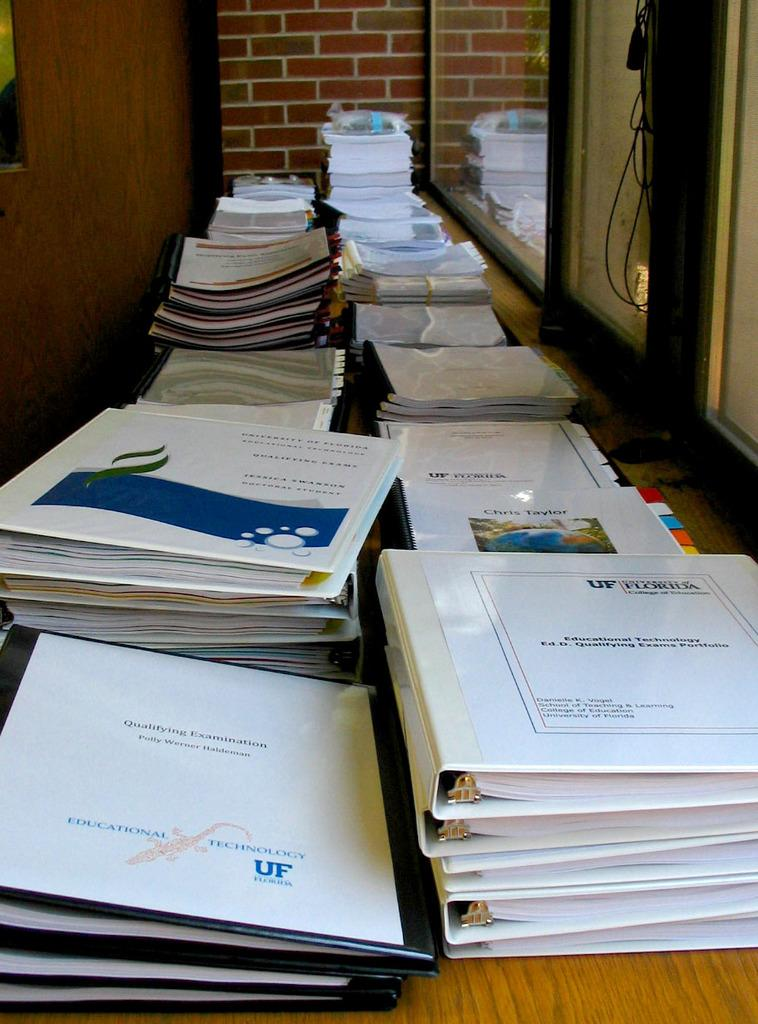Provide a one-sentence caption for the provided image. Stacks of binders filled with Educational Technology Qualifying Exams. 